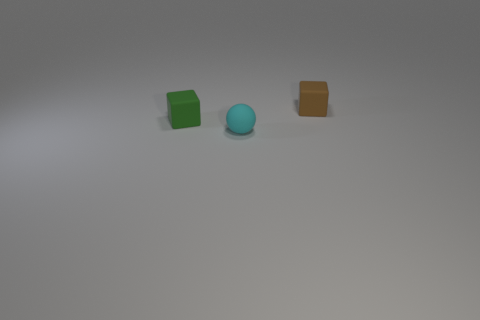Add 3 tiny cubes. How many objects exist? 6 Subtract all balls. How many objects are left? 2 Subtract all big blue shiny balls. Subtract all brown rubber blocks. How many objects are left? 2 Add 3 matte objects. How many matte objects are left? 6 Add 1 tiny brown things. How many tiny brown things exist? 2 Subtract 1 cyan balls. How many objects are left? 2 